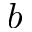<formula> <loc_0><loc_0><loc_500><loc_500>b</formula> 